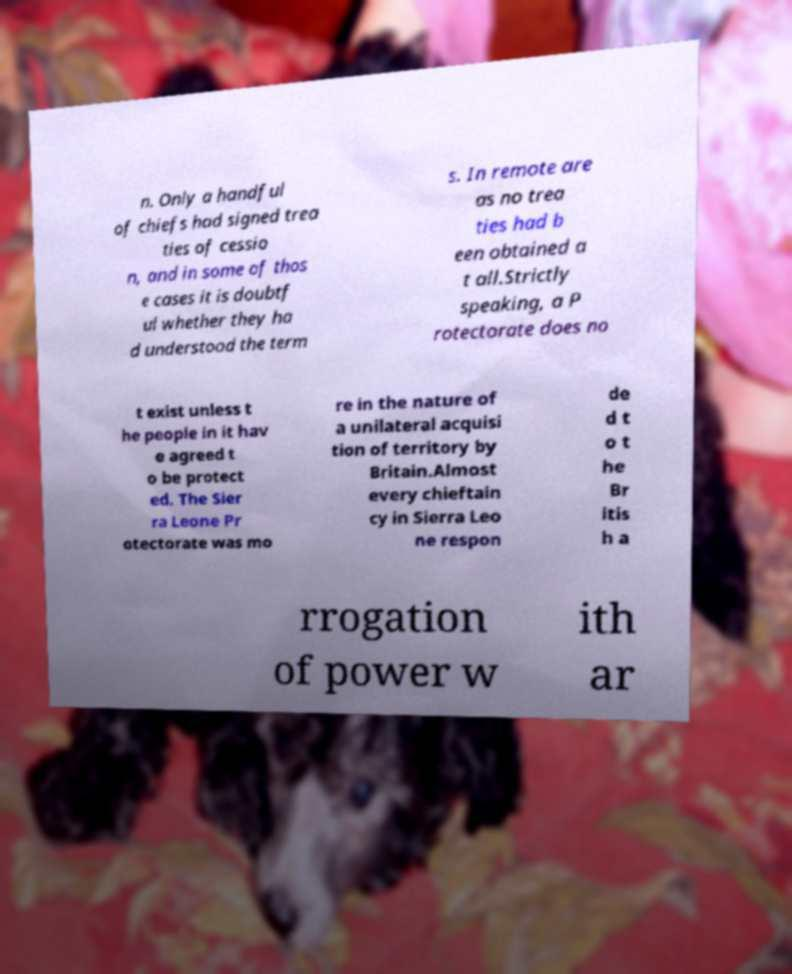Can you read and provide the text displayed in the image?This photo seems to have some interesting text. Can you extract and type it out for me? n. Only a handful of chiefs had signed trea ties of cessio n, and in some of thos e cases it is doubtf ul whether they ha d understood the term s. In remote are as no trea ties had b een obtained a t all.Strictly speaking, a P rotectorate does no t exist unless t he people in it hav e agreed t o be protect ed. The Sier ra Leone Pr otectorate was mo re in the nature of a unilateral acquisi tion of territory by Britain.Almost every chieftain cy in Sierra Leo ne respon de d t o t he Br itis h a rrogation of power w ith ar 